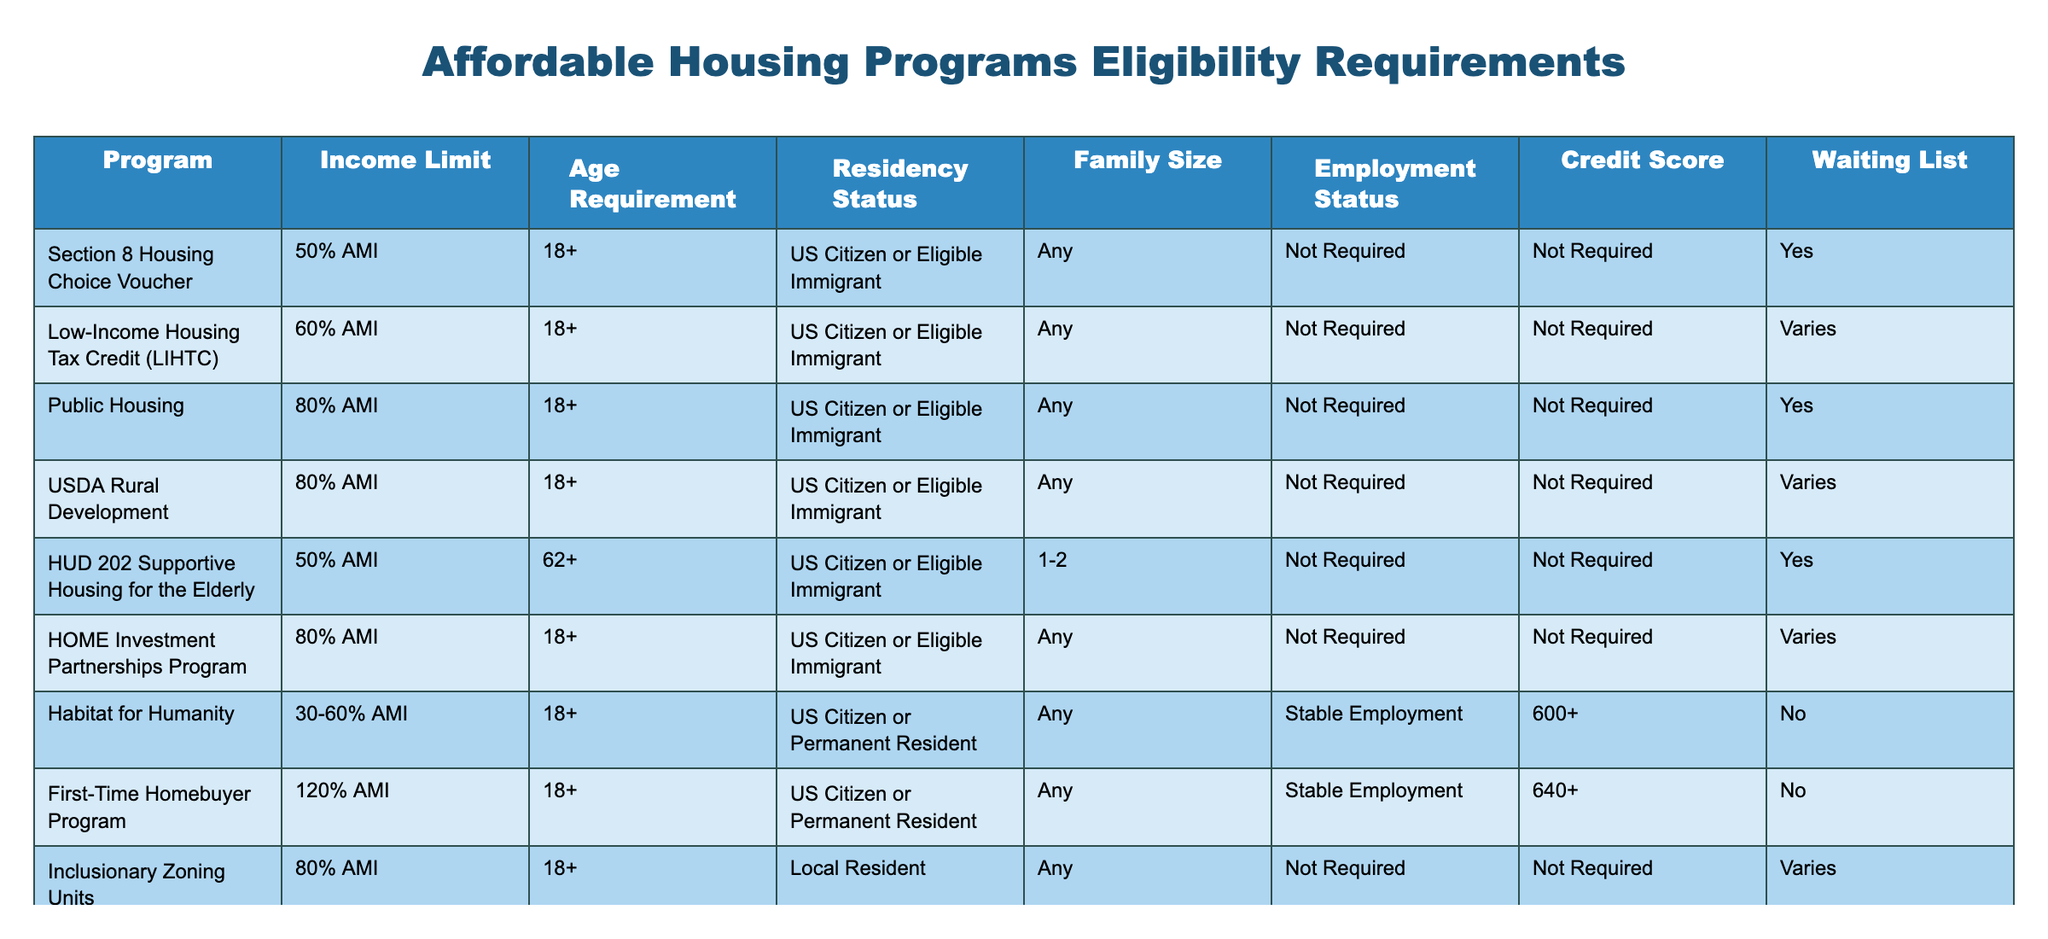What is the income limit for the Section 8 Housing Choice Voucher program? According to the table, the income limit for the Section 8 Housing Choice Voucher program is 50% AMI.
Answer: 50% AMI Which programs have an age requirement of 18 or older? Reviewing the table, the following programs have an age requirement of 18 or older: Section 8 Housing Choice Voucher, Low-Income Housing Tax Credit, Public Housing, USDA Rural Development, HOME Investment Partnerships Program, Inclusionary Zoning Units, and First-Time Homebuyer Program.
Answer: 7 programs Is stable employment required for the Habitat for Humanity program? The table indicates that stable employment is required for the Habitat for Humanity program, which is marked as "Stable Employment" in the Employment Status column.
Answer: Yes How many programs have a waiting list? By counting the "Yes" entries under the Waiting List column, we find that there are 4 programs with a waiting list: Section 8 Housing Choice Voucher, Public Housing, HUD 202 Supportive Housing for the Elderly, and Veterans Affairs Supportive Housing (VASH).
Answer: 4 programs What is the maximum income limit across all programs listed? After analyzing the Income Limits, the highest value is 120% AMI for the First-Time Homebuyer Program, while other programs have lower caps. Thus, the maximum income limit across all programs is 120% AMI.
Answer: 120% AMI Which program is specifically for eligible veterans? From the table, the program designated for eligible veterans is the Veterans Affairs Supportive Housing (VASH), which specifies "Eligible Veteran" under the Residency Status column.
Answer: Veterans Affairs Supportive Housing (VASH) Are there any programs that require a credit score? By examining the Credit Score column, only the Habitat for Humanity and First-Time Homebuyer Program specify a requirement for credit scores, with values of 600+ and 640+ respectively.
Answer: Yes What is the average income limit of programs available for families of any size? Calculating the average income limit for programs available for any family size (ignoring Habitat for Humanity and First-Time Homebuyer Program since they have specific limits): (50% + 60% + 80% + 80% + 80% + 80%) / 6 = 70% AMI. The average is 70% AMI.
Answer: 70% AMI 